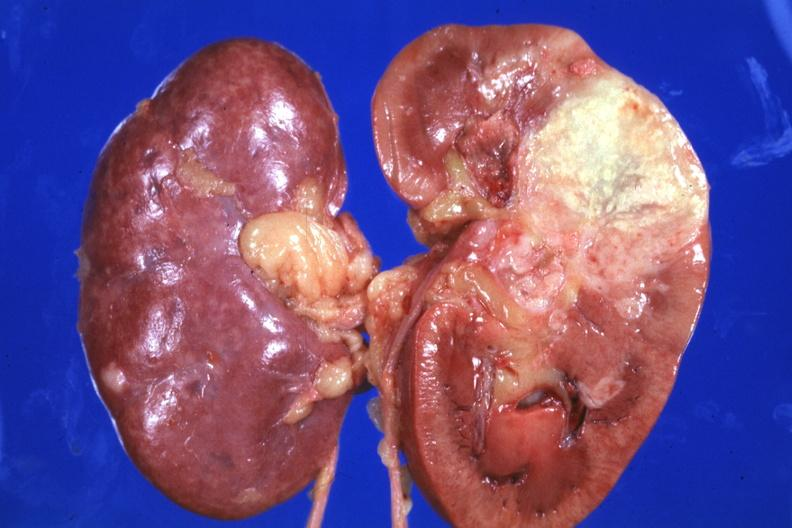does lymphangiomatosis generalized show single large lesion quite good?
Answer the question using a single word or phrase. No 